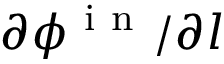<formula> <loc_0><loc_0><loc_500><loc_500>\partial \phi ^ { i n } / \partial l</formula> 